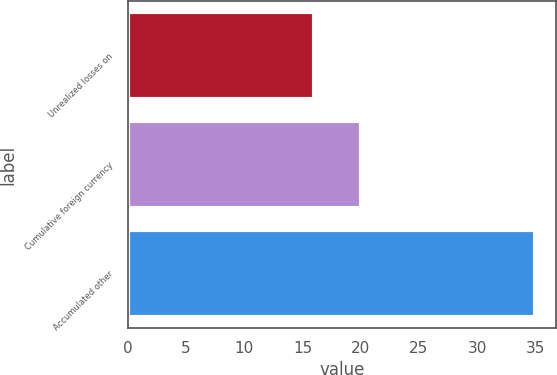Convert chart. <chart><loc_0><loc_0><loc_500><loc_500><bar_chart><fcel>Unrealized losses on<fcel>Cumulative foreign currency<fcel>Accumulated other<nl><fcel>16<fcel>20<fcel>35<nl></chart> 